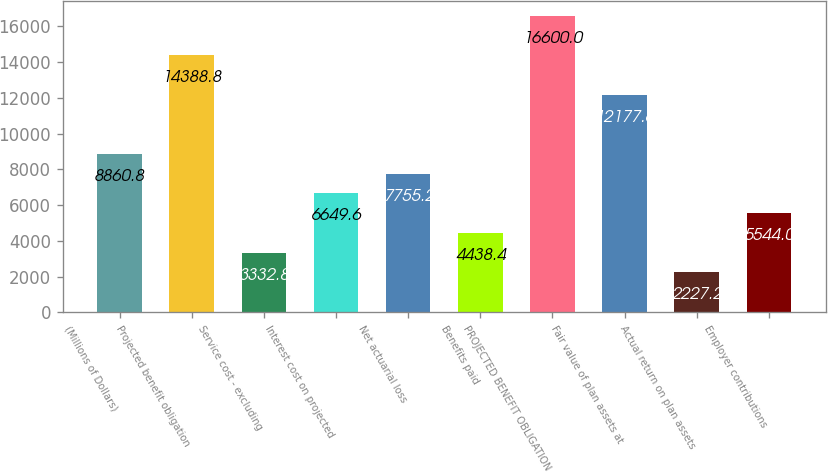Convert chart. <chart><loc_0><loc_0><loc_500><loc_500><bar_chart><fcel>(Millions of Dollars)<fcel>Projected benefit obligation<fcel>Service cost - excluding<fcel>Interest cost on projected<fcel>Net actuarial loss<fcel>Benefits paid<fcel>PROJECTED BENEFIT OBLIGATION<fcel>Fair value of plan assets at<fcel>Actual return on plan assets<fcel>Employer contributions<nl><fcel>8860.8<fcel>14388.8<fcel>3332.8<fcel>6649.6<fcel>7755.2<fcel>4438.4<fcel>16600<fcel>12177.6<fcel>2227.2<fcel>5544<nl></chart> 